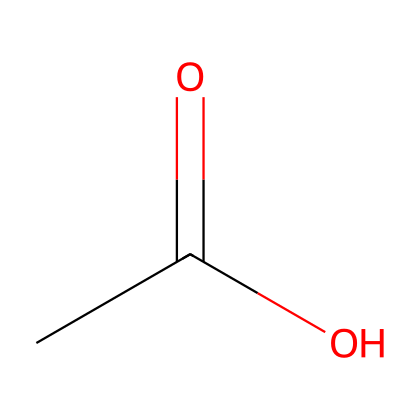What is the common name of the compound represented by this SMILES? The SMILES structure CC(=O)O corresponds to acetic acid, which is commonly known as vinegar.
Answer: acetic acid How many carbon atoms are present in acetic acid? The structure shows one carbon atom in the CC portion, indicating there is just one carbon atom in acetic acid.
Answer: one What functional group is present in acetic acid? The presence of the -COOH group in the structure indicates that acetic acid contains a carboxylic acid functional group.
Answer: carboxylic acid What is the total number of hydrogen atoms in acetic acid? In the SMILES representation, there are three hydrogen atoms connected to carbon (from CC), and one hydrogen connected to oxygen in the -COOH group, giving a total of four hydrogen atoms.
Answer: four Is acetic acid an organic acid or inorganic acid? Acetic acid, with its carbon-based structure, is classified as an organic acid.
Answer: organic acid What characteristic property does acetic acid provide in art projects? Acetic acid is known for its ability to act as a preservative and a medium that can enhance color vibrancy when mixed with pigments.
Answer: preservative 